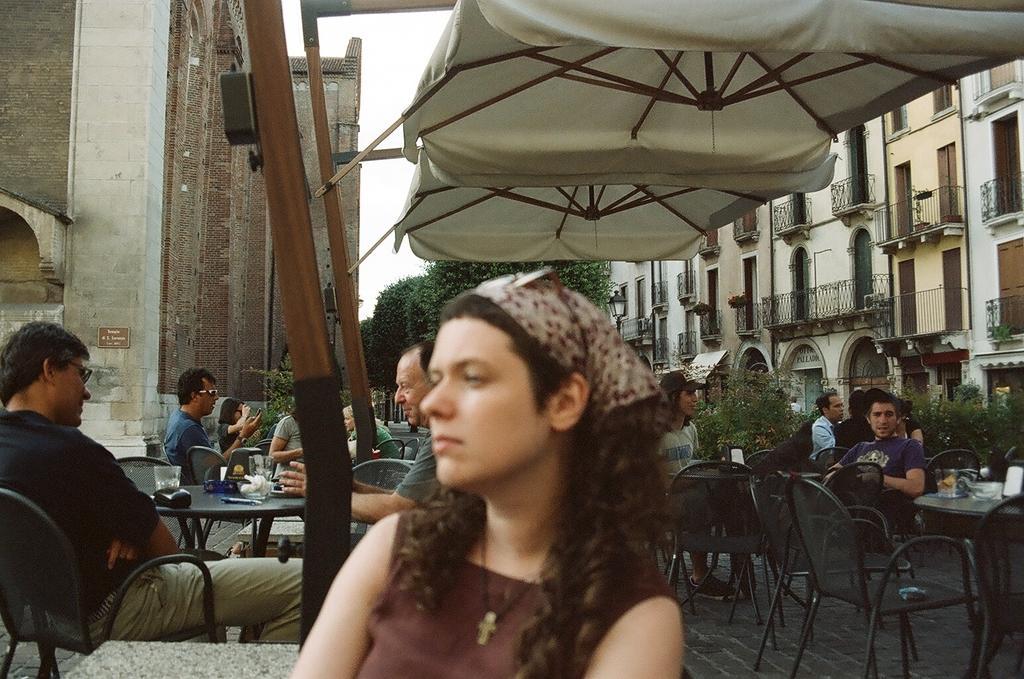In one or two sentences, can you explain what this image depicts? In this picture, there is a woman who is wearing a brown dress and a chain on her neck. She is wearing a scarf and goggles on her head. On to the left, there is a man who is wearing a black dress and is sitting on the chair. There is a glass on the table. There are group of people sitting on the chair. On to the right, there is a man sitting on the chair. There is a woman who is also sitting on the chair and she is wearing a cap on her head. There is a building at the background and a tree. There is a sun shade. 